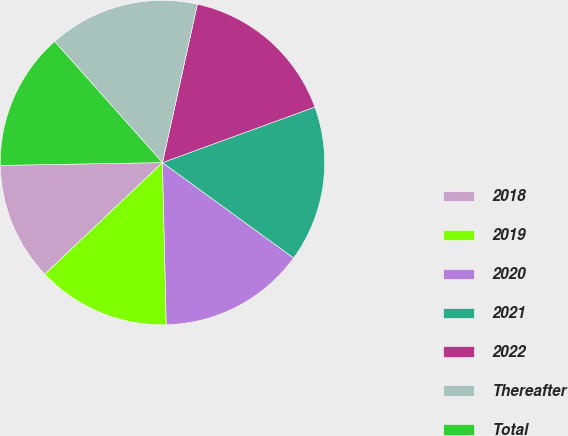Convert chart. <chart><loc_0><loc_0><loc_500><loc_500><pie_chart><fcel>2018<fcel>2019<fcel>2020<fcel>2021<fcel>2022<fcel>Thereafter<fcel>Total<nl><fcel>11.81%<fcel>13.29%<fcel>14.62%<fcel>15.57%<fcel>15.98%<fcel>15.03%<fcel>13.7%<nl></chart> 